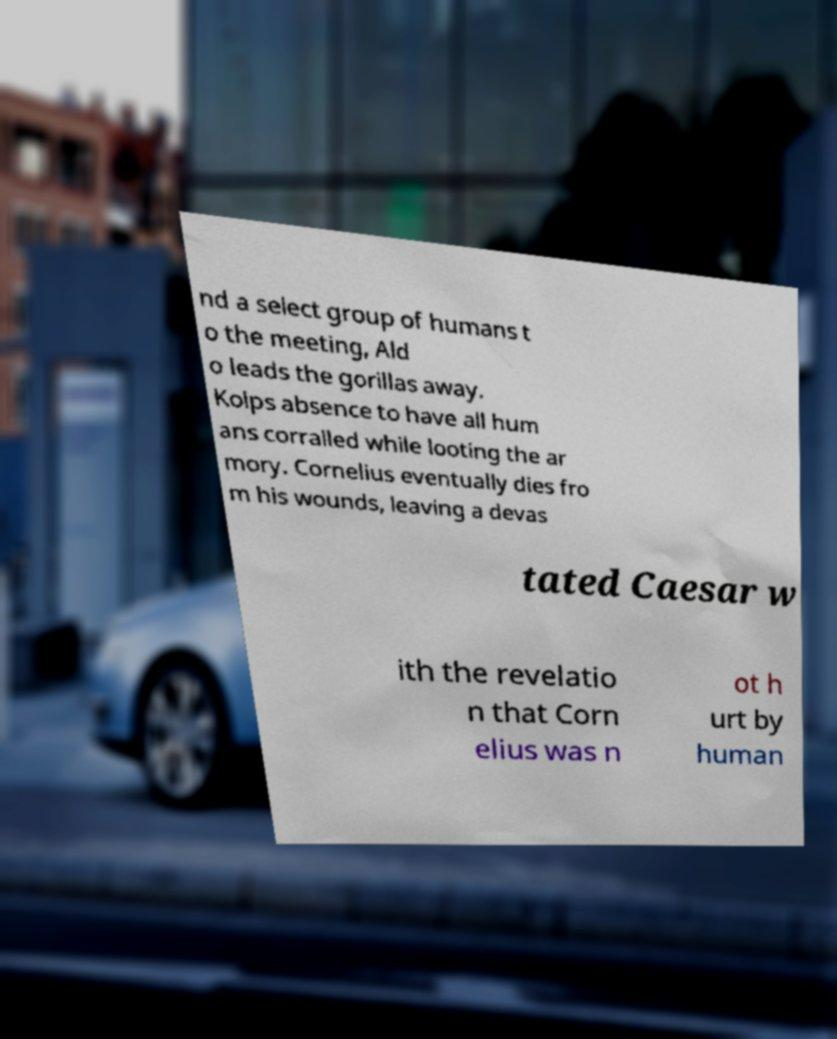I need the written content from this picture converted into text. Can you do that? nd a select group of humans t o the meeting, Ald o leads the gorillas away. Kolps absence to have all hum ans corralled while looting the ar mory. Cornelius eventually dies fro m his wounds, leaving a devas tated Caesar w ith the revelatio n that Corn elius was n ot h urt by human 